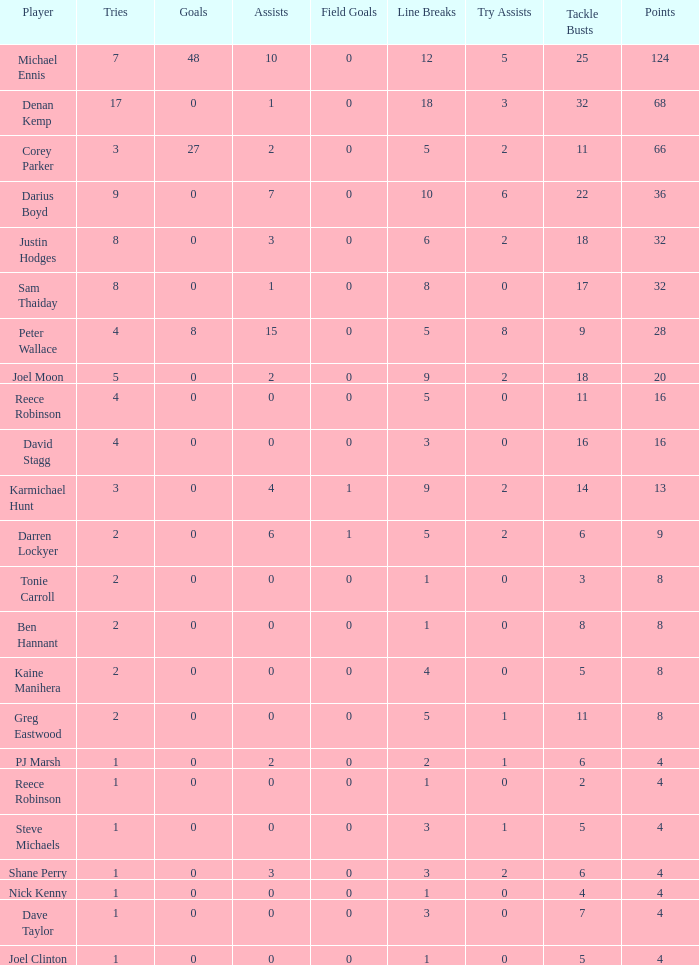What is the lowest tries the player with more than 0 goals, 28 points, and more than 0 field goals have? None. 